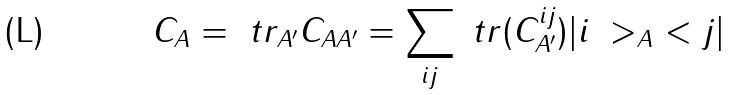Convert formula to latex. <formula><loc_0><loc_0><loc_500><loc_500>C _ { A } = \ t r _ { A ^ { \prime } } C _ { A A ^ { \prime } } = \sum _ { i j } \ t r ( C ^ { i j } _ { A ^ { \prime } } ) | i \ > _ { A } \ < j |</formula> 